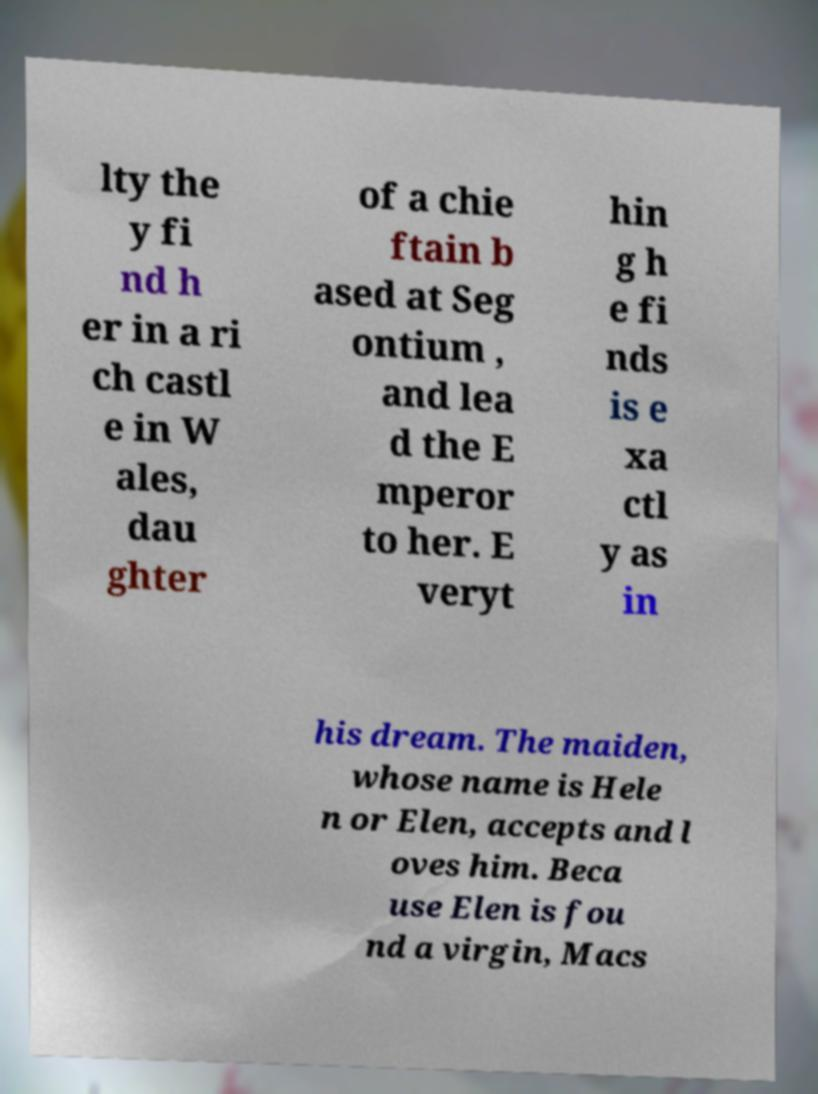I need the written content from this picture converted into text. Can you do that? lty the y fi nd h er in a ri ch castl e in W ales, dau ghter of a chie ftain b ased at Seg ontium , and lea d the E mperor to her. E veryt hin g h e fi nds is e xa ctl y as in his dream. The maiden, whose name is Hele n or Elen, accepts and l oves him. Beca use Elen is fou nd a virgin, Macs 